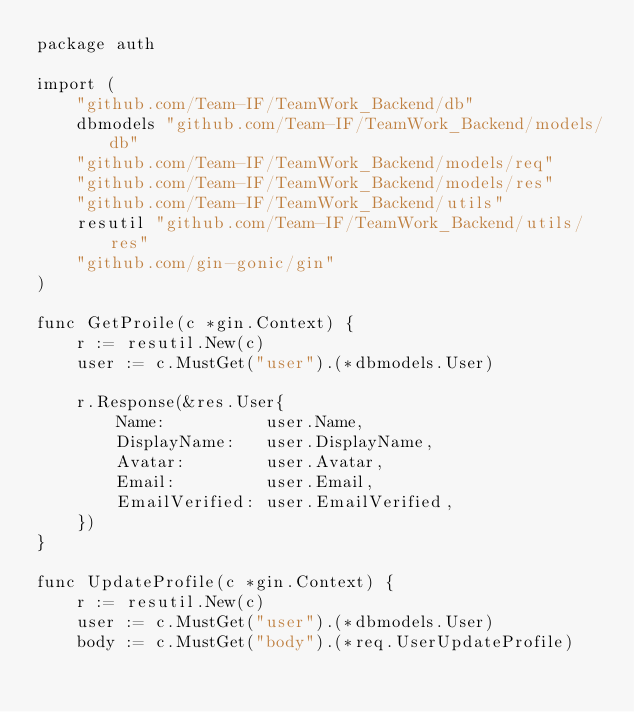Convert code to text. <code><loc_0><loc_0><loc_500><loc_500><_Go_>package auth

import (
	"github.com/Team-IF/TeamWork_Backend/db"
	dbmodels "github.com/Team-IF/TeamWork_Backend/models/db"
	"github.com/Team-IF/TeamWork_Backend/models/req"
	"github.com/Team-IF/TeamWork_Backend/models/res"
	"github.com/Team-IF/TeamWork_Backend/utils"
	resutil "github.com/Team-IF/TeamWork_Backend/utils/res"
	"github.com/gin-gonic/gin"
)

func GetProile(c *gin.Context) {
	r := resutil.New(c)
	user := c.MustGet("user").(*dbmodels.User)

	r.Response(&res.User{
		Name:          user.Name,
		DisplayName:   user.DisplayName,
		Avatar:        user.Avatar,
		Email:         user.Email,
		EmailVerified: user.EmailVerified,
	})
}

func UpdateProfile(c *gin.Context) {
	r := resutil.New(c)
	user := c.MustGet("user").(*dbmodels.User)
	body := c.MustGet("body").(*req.UserUpdateProfile)
</code> 